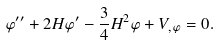<formula> <loc_0><loc_0><loc_500><loc_500>\varphi ^ { \prime \prime } + 2 H \varphi ^ { \prime } - \frac { 3 } { 4 } H ^ { 2 } \varphi + V _ { , \varphi } = 0 .</formula> 